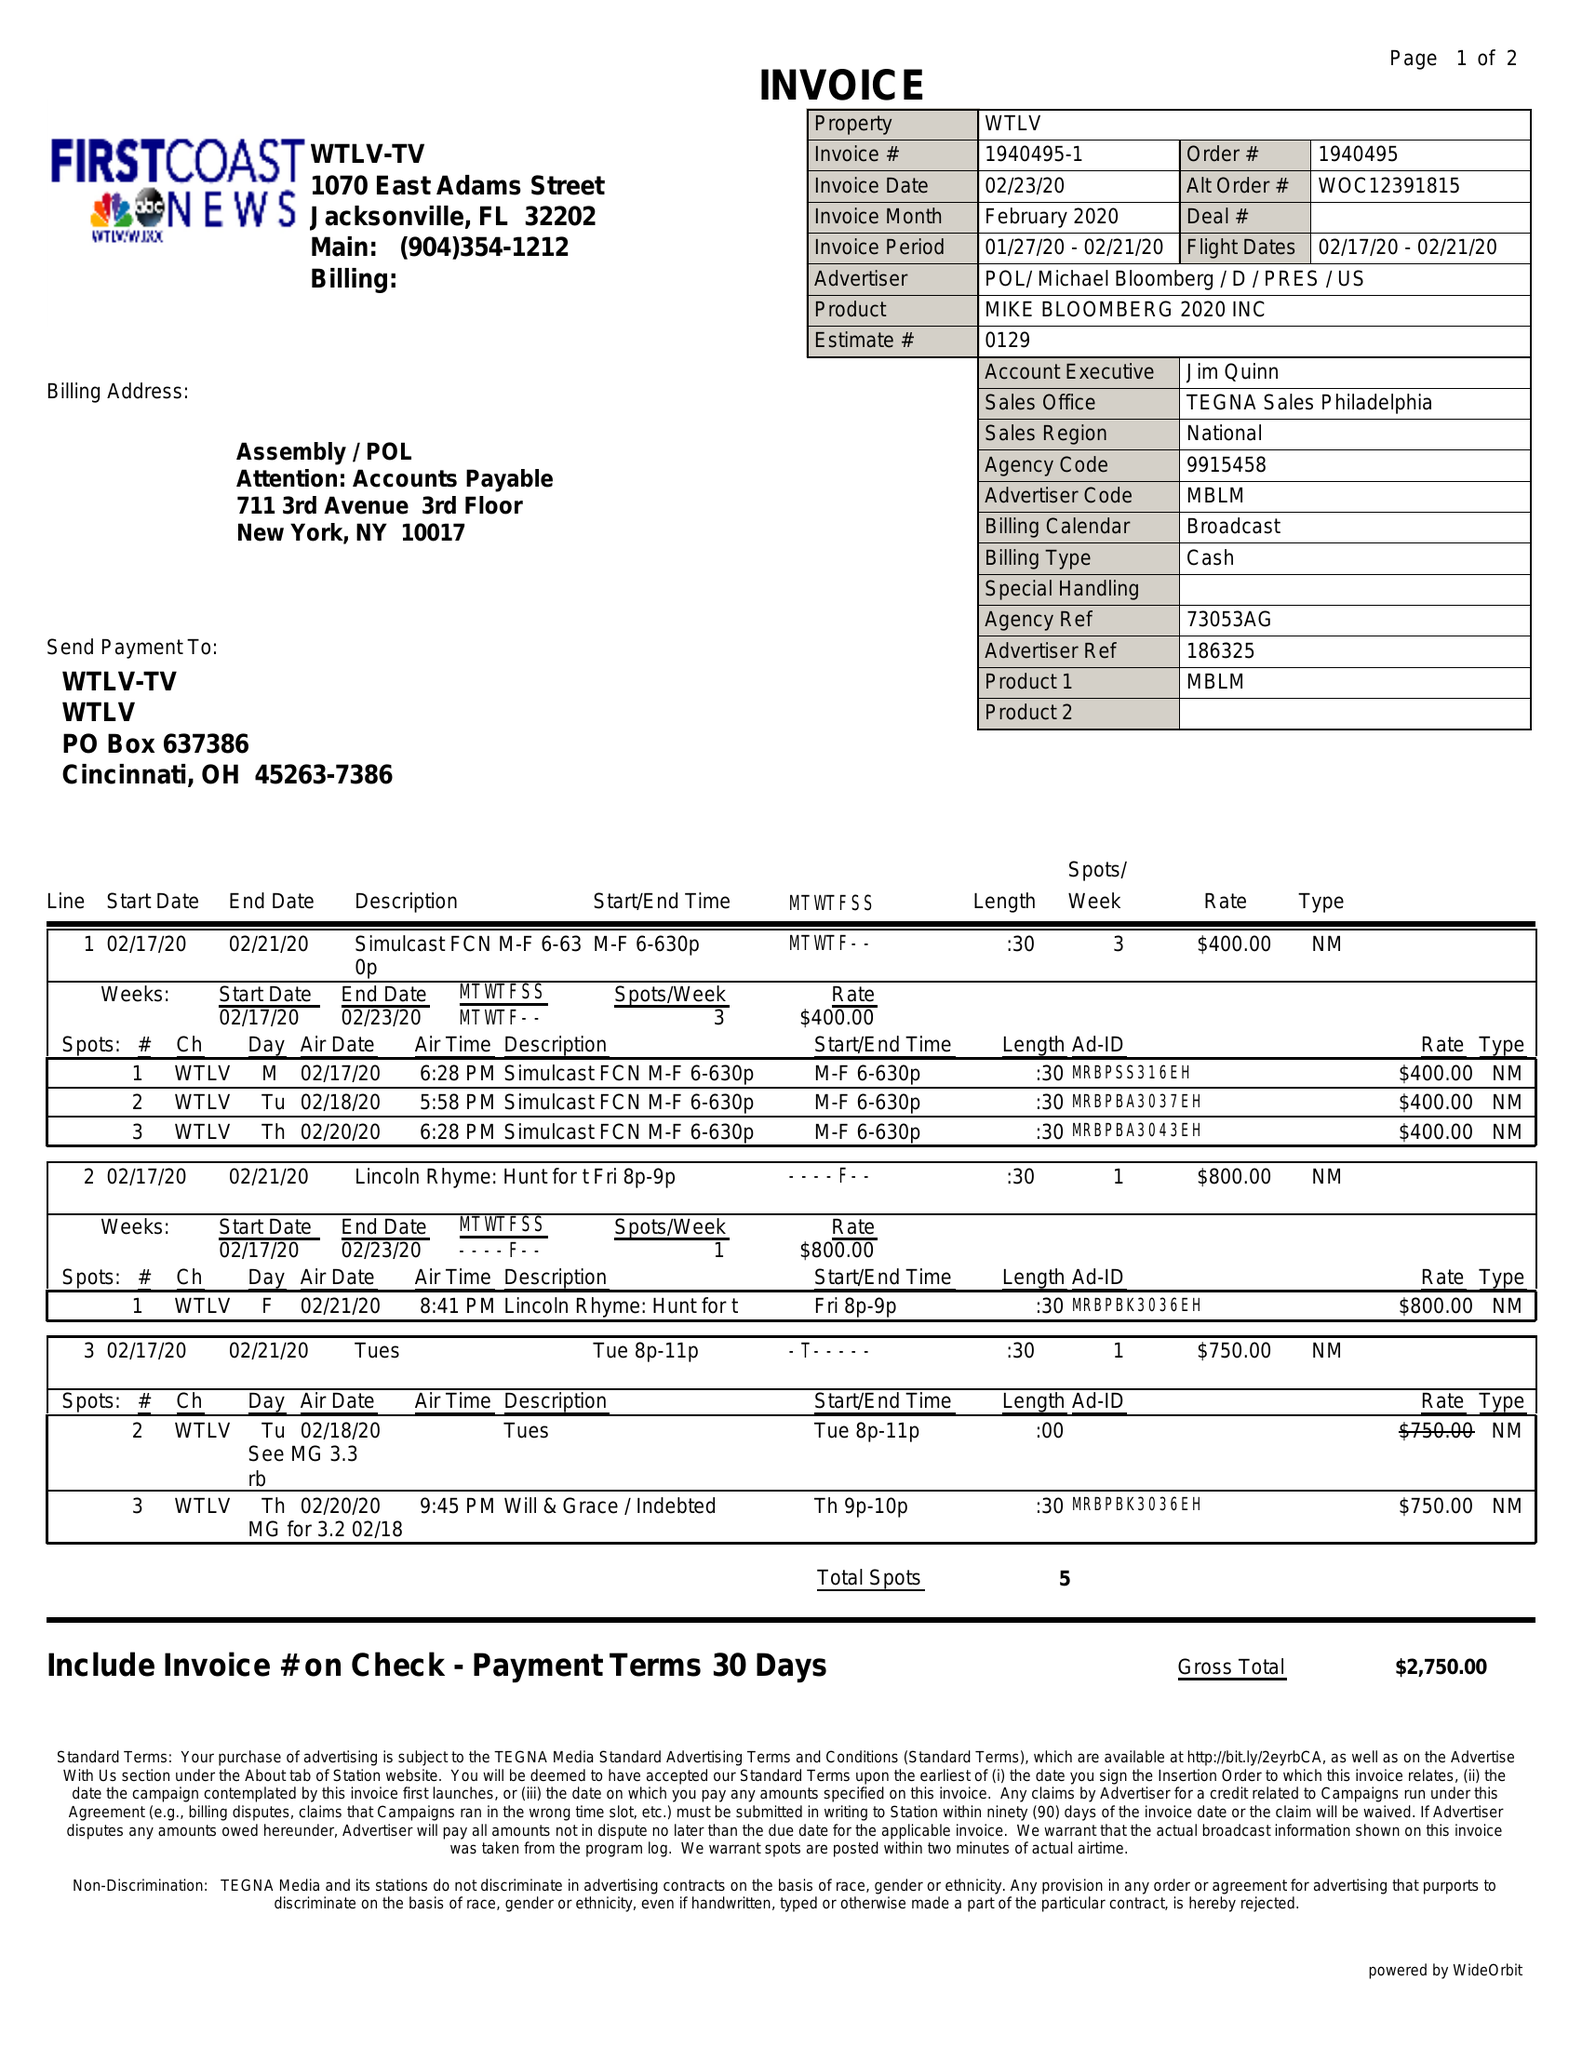What is the value for the flight_from?
Answer the question using a single word or phrase. 02/17/20 